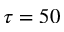Convert formula to latex. <formula><loc_0><loc_0><loc_500><loc_500>\tau = 5 0</formula> 